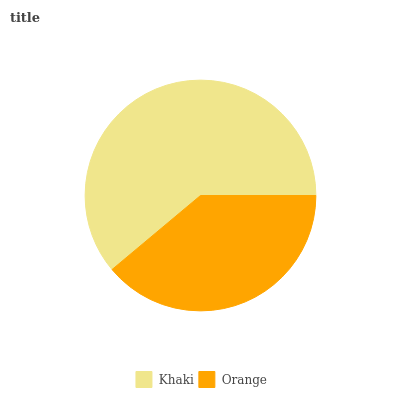Is Orange the minimum?
Answer yes or no. Yes. Is Khaki the maximum?
Answer yes or no. Yes. Is Orange the maximum?
Answer yes or no. No. Is Khaki greater than Orange?
Answer yes or no. Yes. Is Orange less than Khaki?
Answer yes or no. Yes. Is Orange greater than Khaki?
Answer yes or no. No. Is Khaki less than Orange?
Answer yes or no. No. Is Khaki the high median?
Answer yes or no. Yes. Is Orange the low median?
Answer yes or no. Yes. Is Orange the high median?
Answer yes or no. No. Is Khaki the low median?
Answer yes or no. No. 